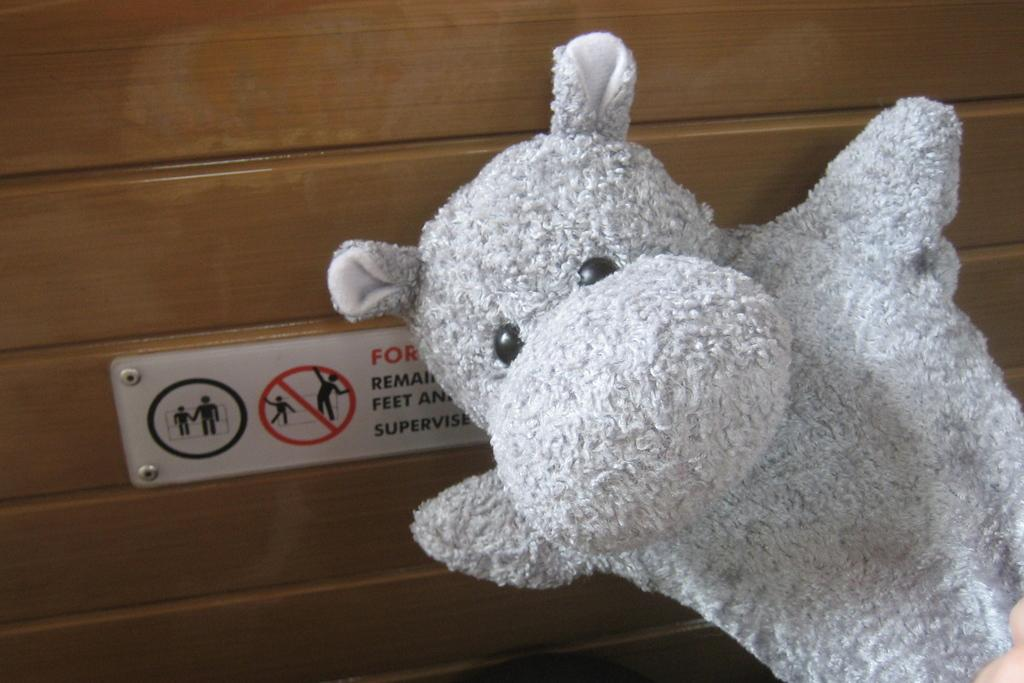What type of object can be seen in the image? There is a white soft toy in the image. What is on the wall in the image? There is a sign board on the wall in the image. How many dolls are sitting on the donkey in the image? There are no dolls or donkeys present in the image. 